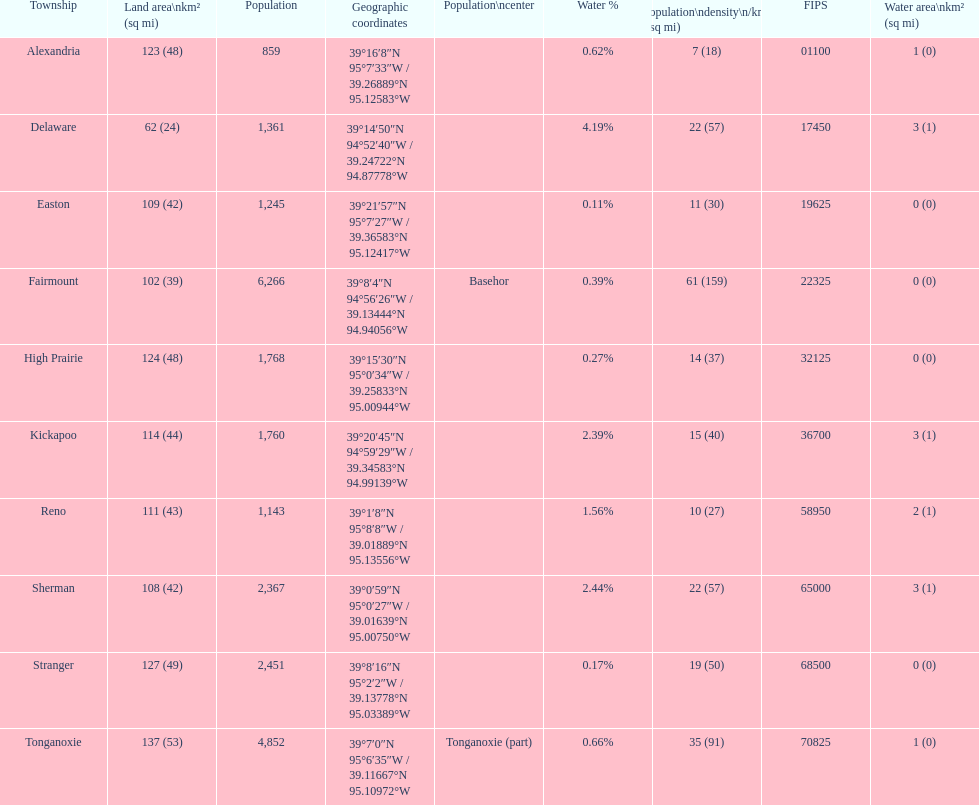What is the number of townships with a population larger than 2,000? 4. 